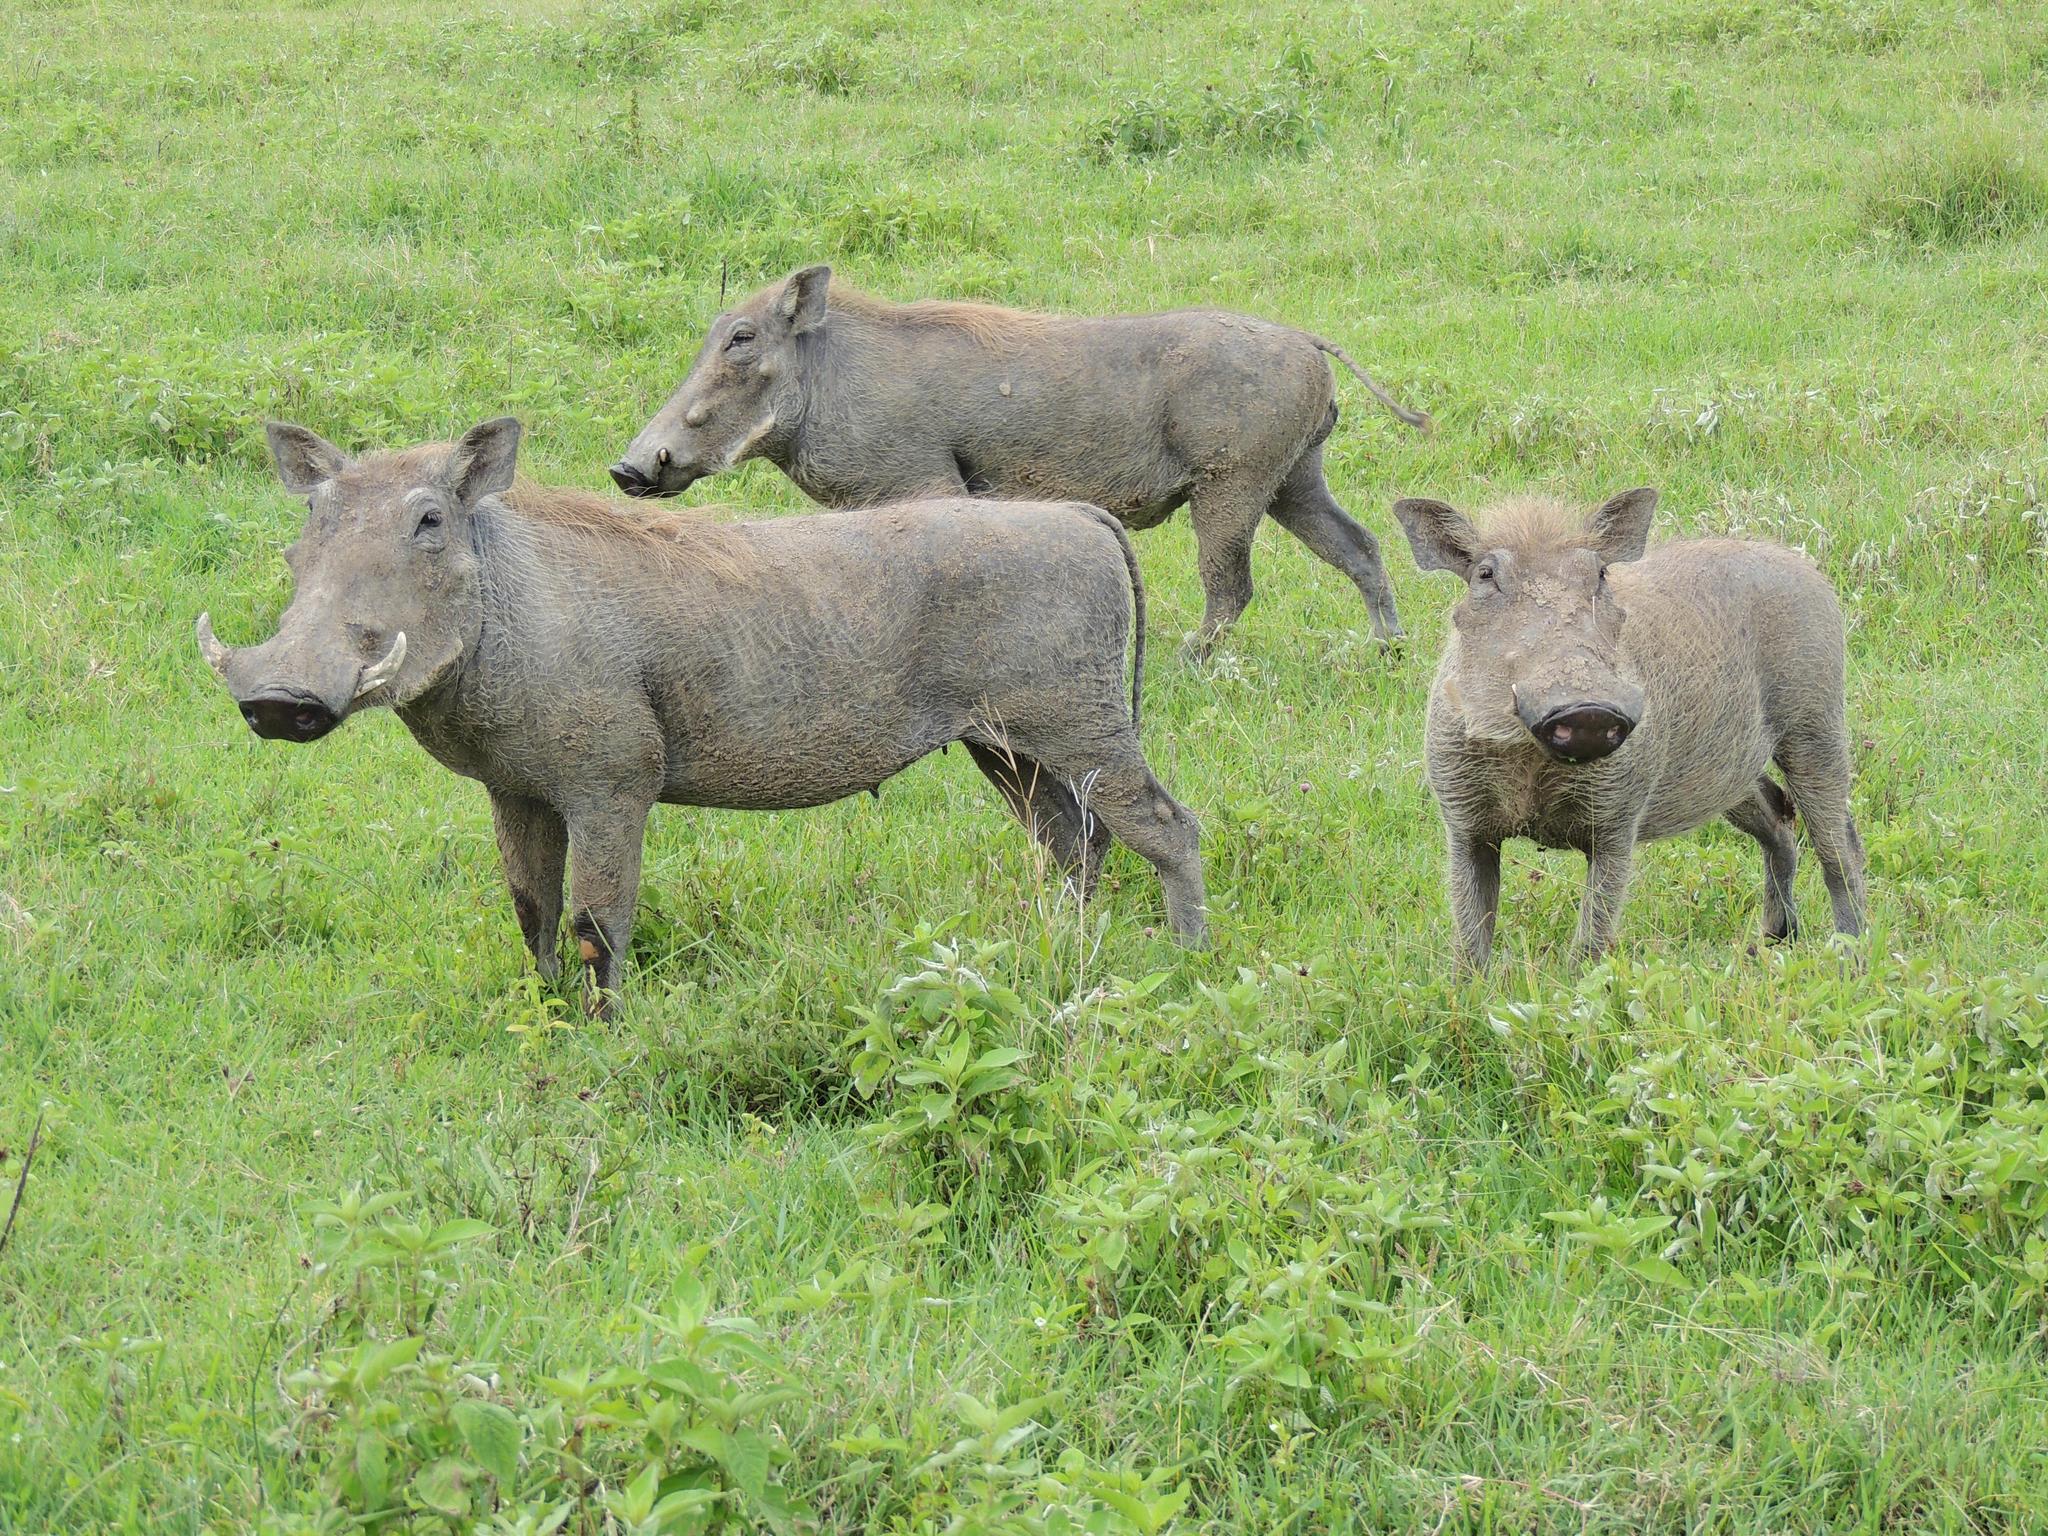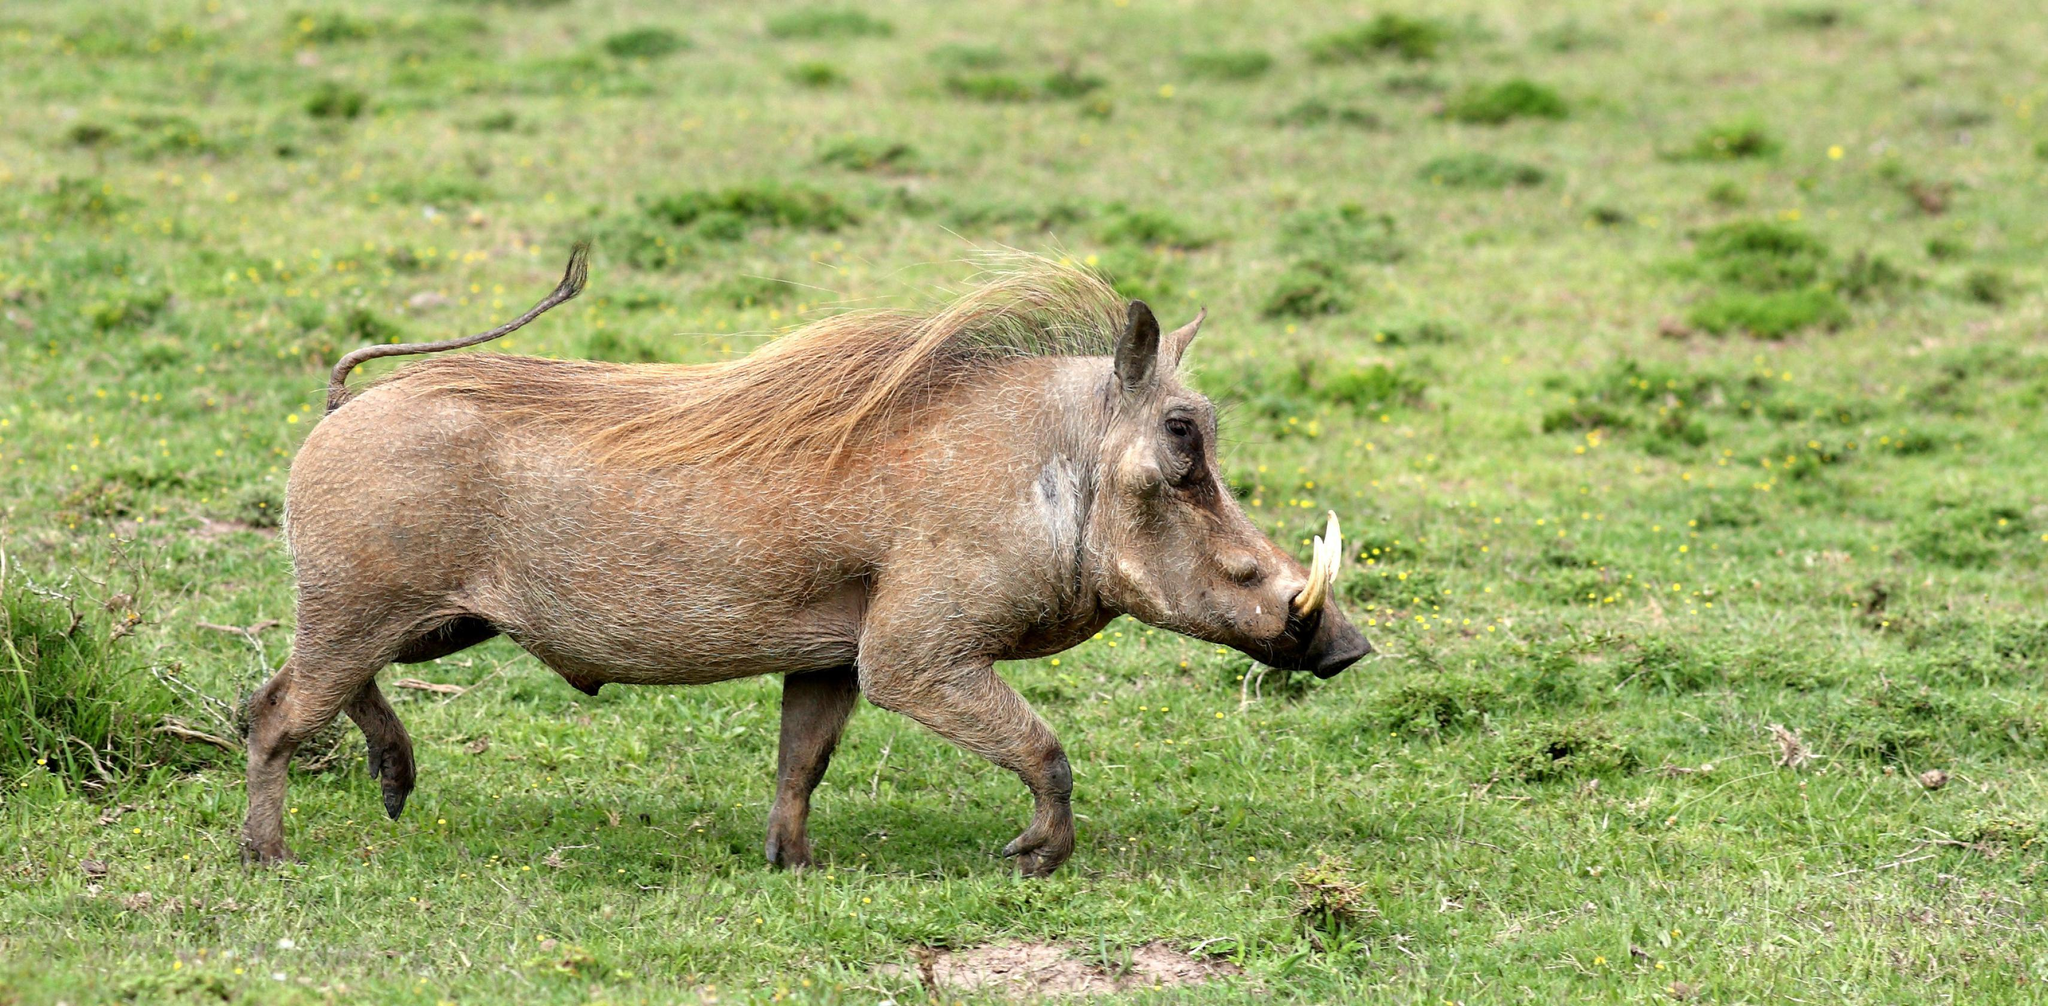The first image is the image on the left, the second image is the image on the right. Examine the images to the left and right. Is the description "One of the images contains only one boar." accurate? Answer yes or no. Yes. 